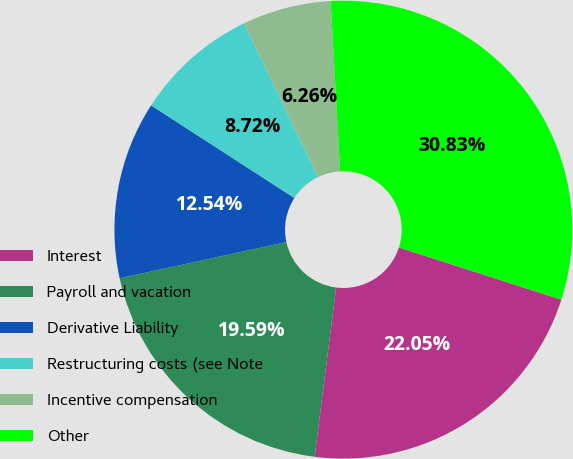Convert chart to OTSL. <chart><loc_0><loc_0><loc_500><loc_500><pie_chart><fcel>Interest<fcel>Payroll and vacation<fcel>Derivative Liability<fcel>Restructuring costs (see Note<fcel>Incentive compensation<fcel>Other<nl><fcel>22.05%<fcel>19.59%<fcel>12.54%<fcel>8.72%<fcel>6.26%<fcel>30.83%<nl></chart> 